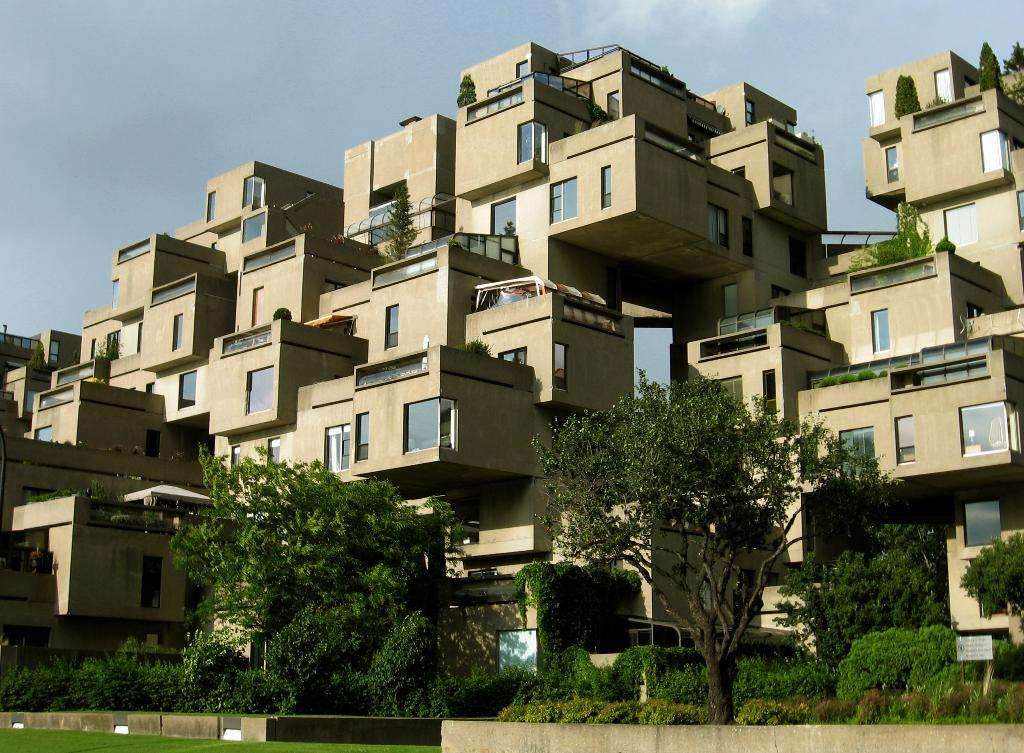What type of natural environment is depicted in the image? There is a lawn in the image, which suggests a natural environment. What type of vegetation can be seen in the image? There are trees and plants in the image. What object can be seen in the foreground of the image? There is a board in the image. What can be seen in the background of the image? There is an architectural building and the sky visible in the background. What type of yak is being used to control the plants in the image? There is no yak present in the image, and no control of plants is depicted. 